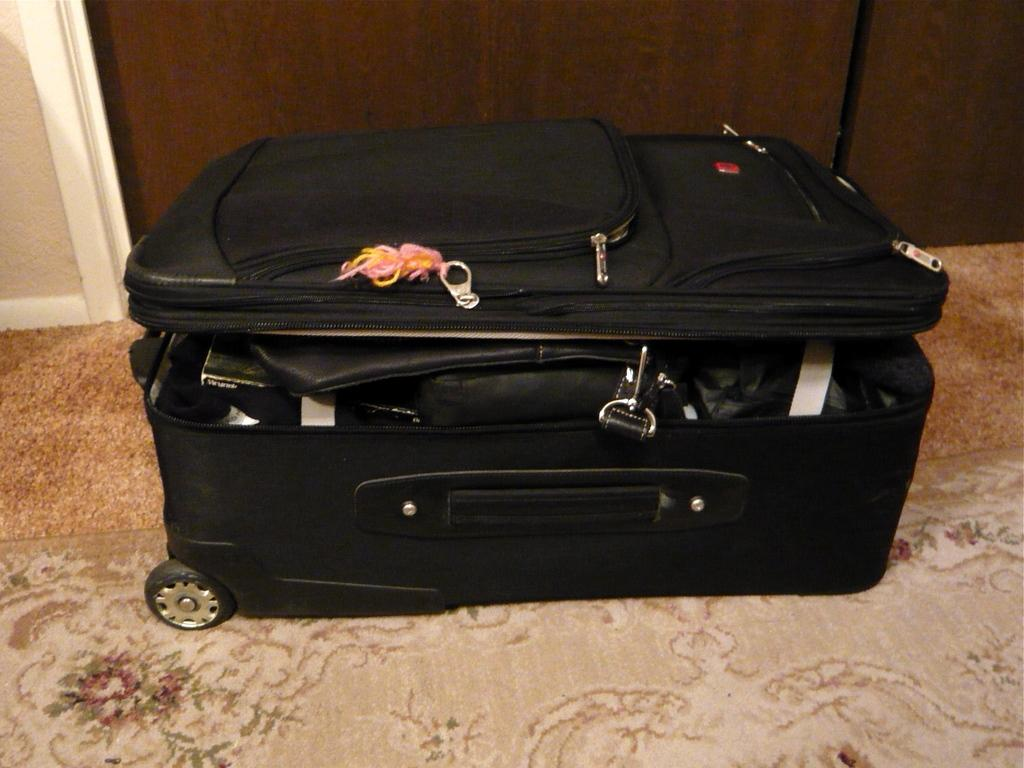What object is present in the image that is commonly used for carrying belongings? There is a suitcase in the image. What features does the suitcase have for ease of use? The suitcase has wheels, a handle, and a lock. What might be found inside the suitcase? There are files inside the suitcase. On what type of floor is the suitcase placed? The suitcase is placed on a carpet floor. What can be seen in the background of the image? There is a wooden wall in the background of the image. What time of day is it in the image, and what is the cat doing? There is no mention of a cat or a specific time of day in the image. 